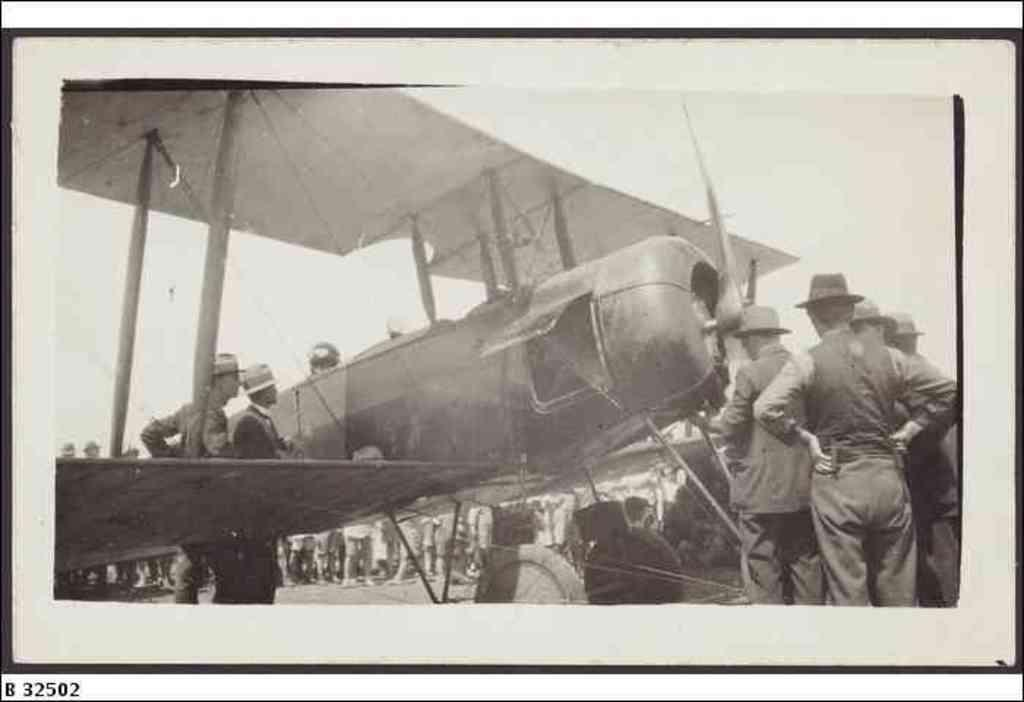What type of picture is in the image? The image contains a black and white picture. What is happening in the picture? The picture depicts a group of people standing. What is the main object in the center of the image? There is an airplane in the center of the image. What can be seen at the top of the image? The sky is visible at the top of the image. What type of birthday celebration is depicted in the image? There is no birthday celebration depicted in the image; it features a group of people standing and an airplane in the center. What industry is represented by the people in the image? The image does not specify any particular industry; it simply shows a group of people standing. 